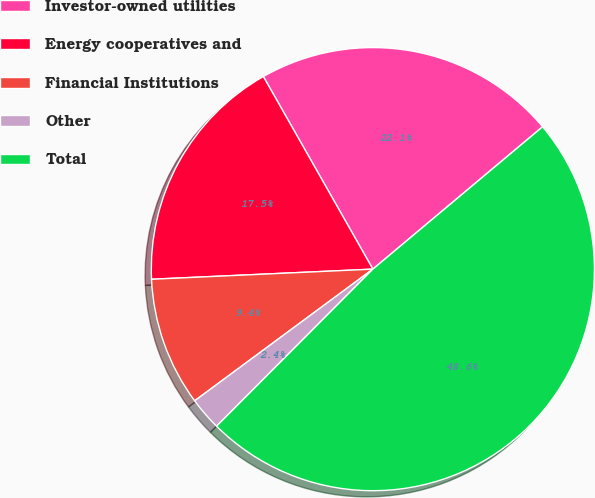Convert chart to OTSL. <chart><loc_0><loc_0><loc_500><loc_500><pie_chart><fcel>Investor-owned utilities<fcel>Energy cooperatives and<fcel>Financial Institutions<fcel>Other<fcel>Total<nl><fcel>22.12%<fcel>17.5%<fcel>9.4%<fcel>2.41%<fcel>48.57%<nl></chart> 